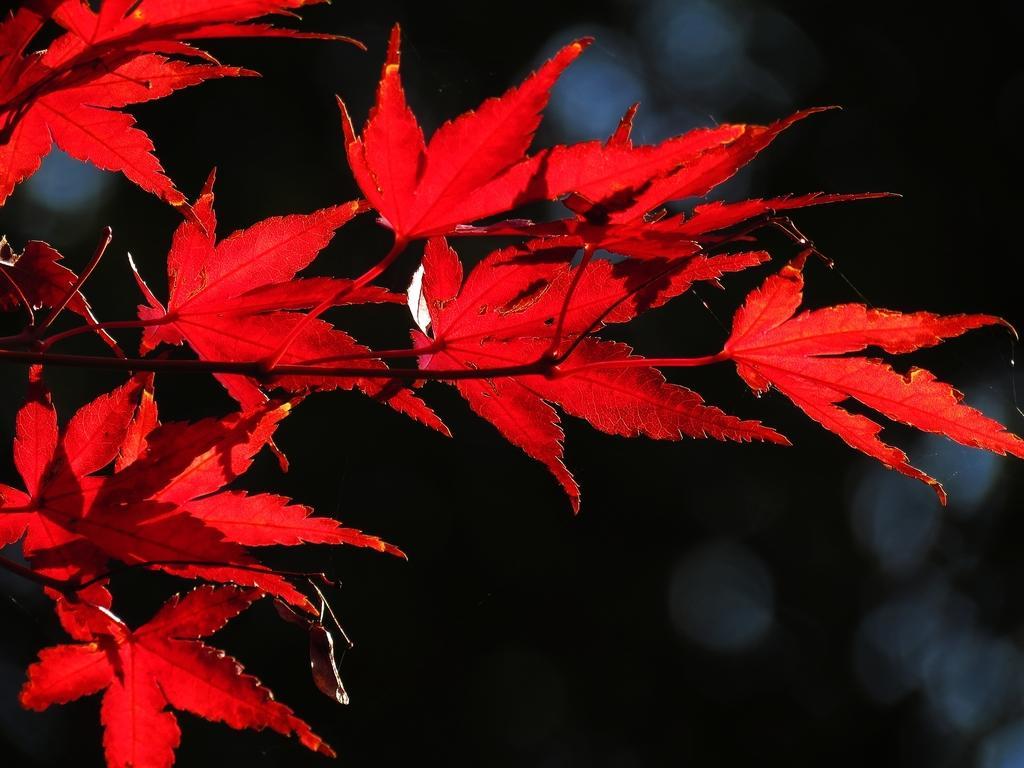Could you give a brief overview of what you see in this image? In this image I can see a tree and dark color. This image is taken may be during night. 